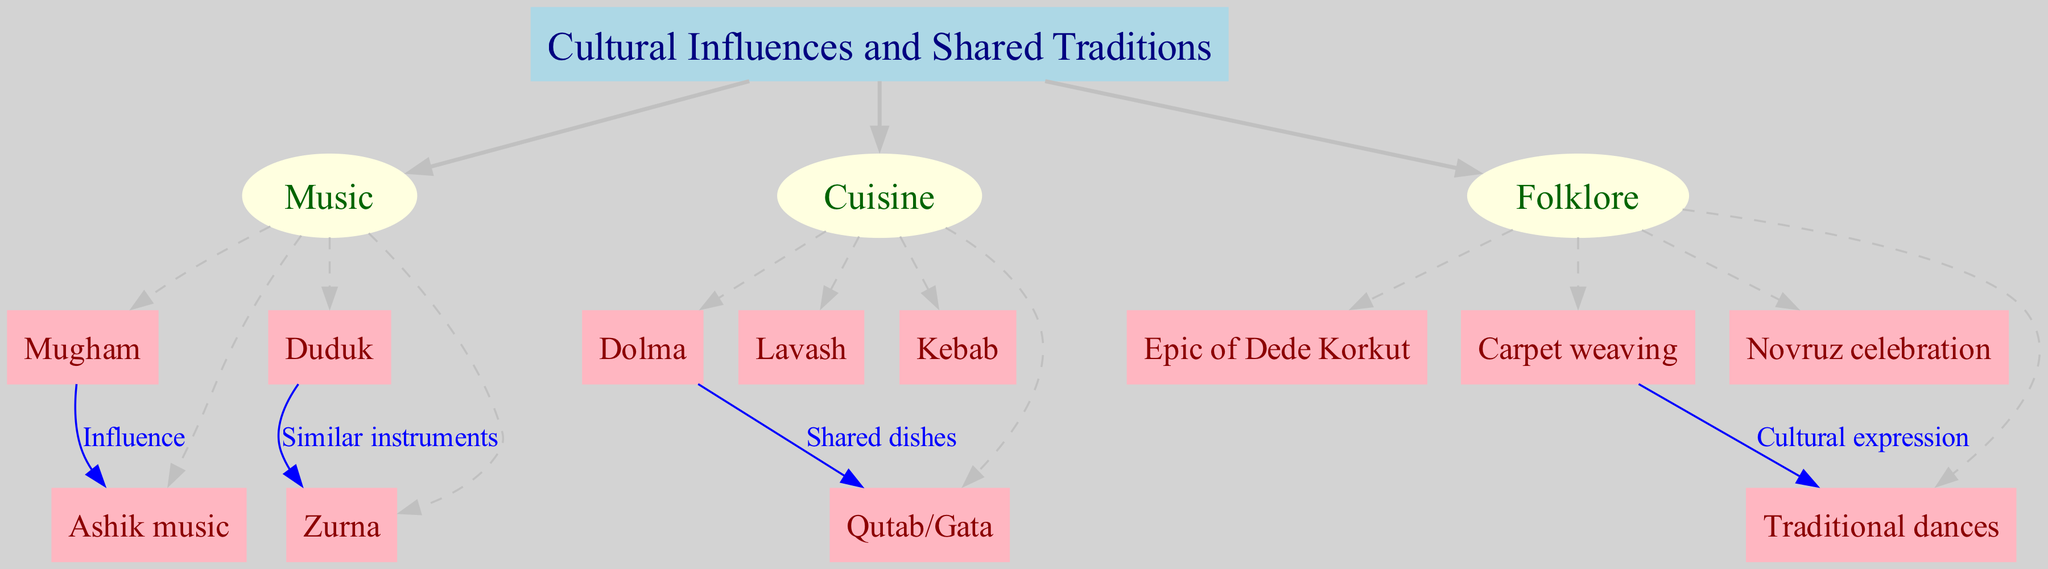What are the three main categories of cultural influences depicted in the diagram? The diagram lists three main categories which are directly connected to the central node "Cultural Influences and Shared Traditions." These categories are visually distinguished and labeled as Music, Cuisine, and Folklore.
Answer: Music, Cuisine, Folklore How many sub-nodes are listed under the category of Cuisine? Under the Cuisine category, there are four distinct sub-nodes: Dolma, Lavash, Kebab, and Qutab/Gata. This can be counted directly from the diagram.
Answer: 4 What type of instrument is shared between Duduk and Zurna? The connection labeled "Similar instruments" indicates that both Duduk and Zurna are recognized as similar types of instruments, showing their relationship visually in the diagram.
Answer: Similar instruments Which sub-node is linked to the Epic of Dede Korkut? The Epic of Dede Korkut is a specific entry under the Folklore category, which is a sub-node of the central node, indicating its association with cultural storytelling and heritage.
Answer: Epic of Dede Korkut What connects Mugham to Ashik music in the diagram? The connection between Mugham and Ashik music is labeled "Influence," signifying a direct cultural influence from Mugham to Ashik music, which is evident from the directed edge in the diagram.
Answer: Influence What are the shared dishes listed under the category of Cuisine? The diagram indicates the shared dishes between Cuisine sub-nodes as Dolma and Qutab/Gata through the connection labeled "Shared dishes." This can be verified by examining the connections and sub-nodes under Cuisine.
Answer: Dolma, Qutab/Gata What cultural expression is represented by the connection between Carpet weaving and Traditional dances? The label for the connection between Carpet weaving and Traditional dances is "Cultural expression," emphasizing their role in reflecting cultural practices visually represented in the diagram.
Answer: Cultural expression How many sub-nodes are associated with Music? The Music category includes four sub-nodes: Mugham, Duduk, Zurna, and Ashik music. This can be counted directly from the connections shown in the diagram.
Answer: 4 What is the relationship labeled between Dolma and Qutab/Gata? The relationship labeled between Dolma and Qutab/Gata is "Shared dishes," illustrating a commonality within the cuisine of both cultures, which is explicitly stated on the connecting edge in the diagram.
Answer: Shared dishes 